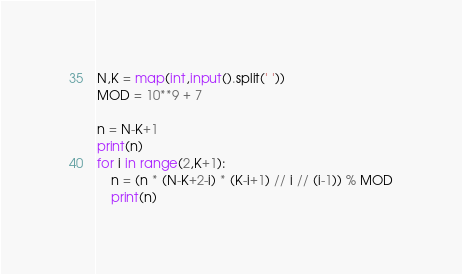Convert code to text. <code><loc_0><loc_0><loc_500><loc_500><_Python_>N,K = map(int,input().split(' '))
MOD = 10**9 + 7

n = N-K+1
print(n)
for i in range(2,K+1):
	n = (n * (N-K+2-i) * (K-i+1) // i // (i-1)) % MOD
	print(n)
</code> 